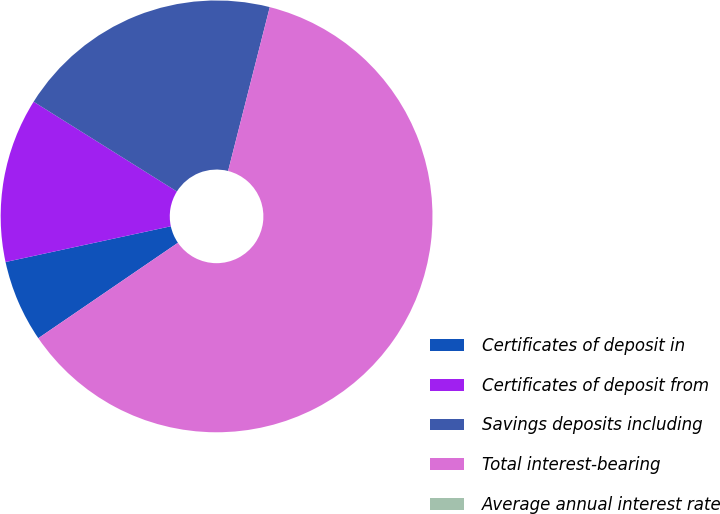<chart> <loc_0><loc_0><loc_500><loc_500><pie_chart><fcel>Certificates of deposit in<fcel>Certificates of deposit from<fcel>Savings deposits including<fcel>Total interest-bearing<fcel>Average annual interest rate<nl><fcel>6.15%<fcel>12.3%<fcel>20.05%<fcel>61.49%<fcel>0.0%<nl></chart> 